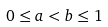Convert formula to latex. <formula><loc_0><loc_0><loc_500><loc_500>0 \leq a < b \leq 1</formula> 